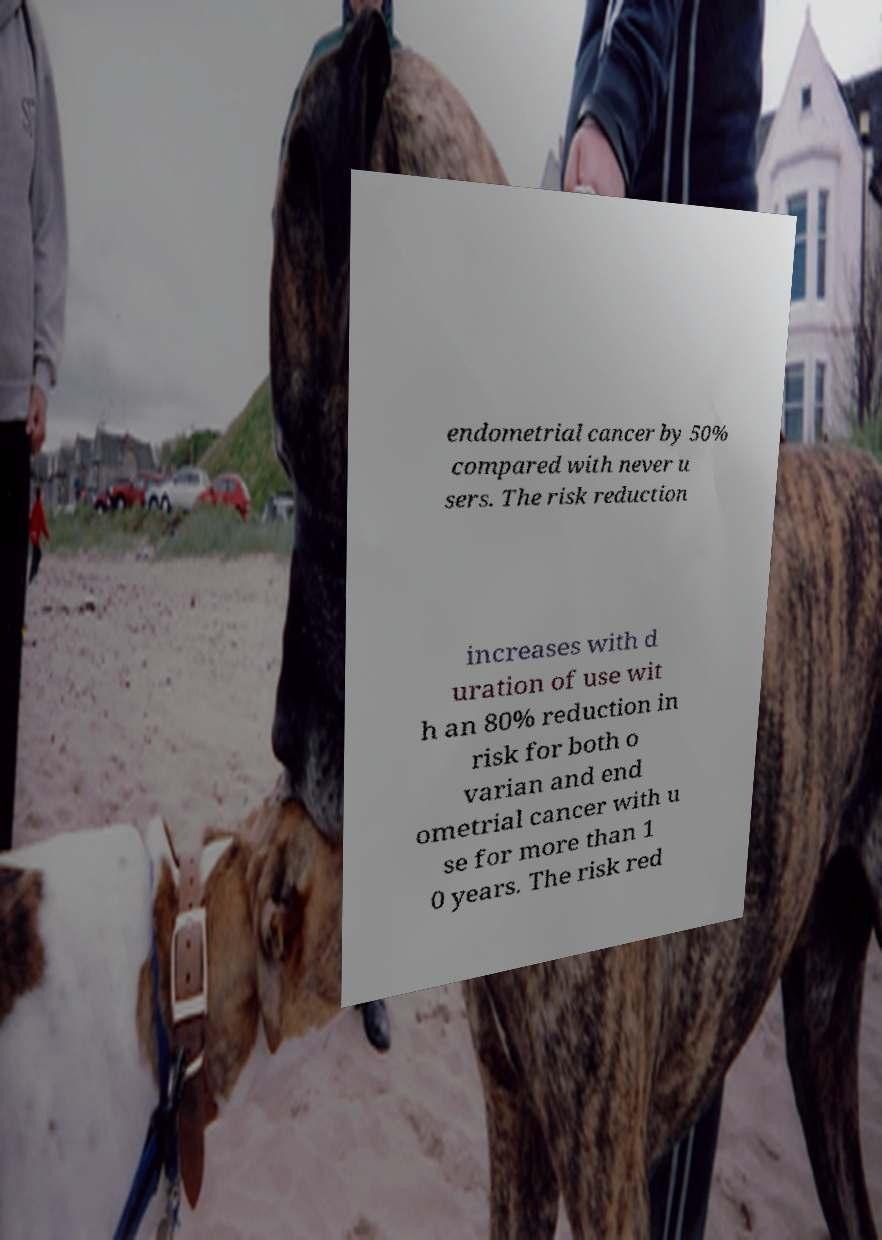There's text embedded in this image that I need extracted. Can you transcribe it verbatim? endometrial cancer by 50% compared with never u sers. The risk reduction increases with d uration of use wit h an 80% reduction in risk for both o varian and end ometrial cancer with u se for more than 1 0 years. The risk red 